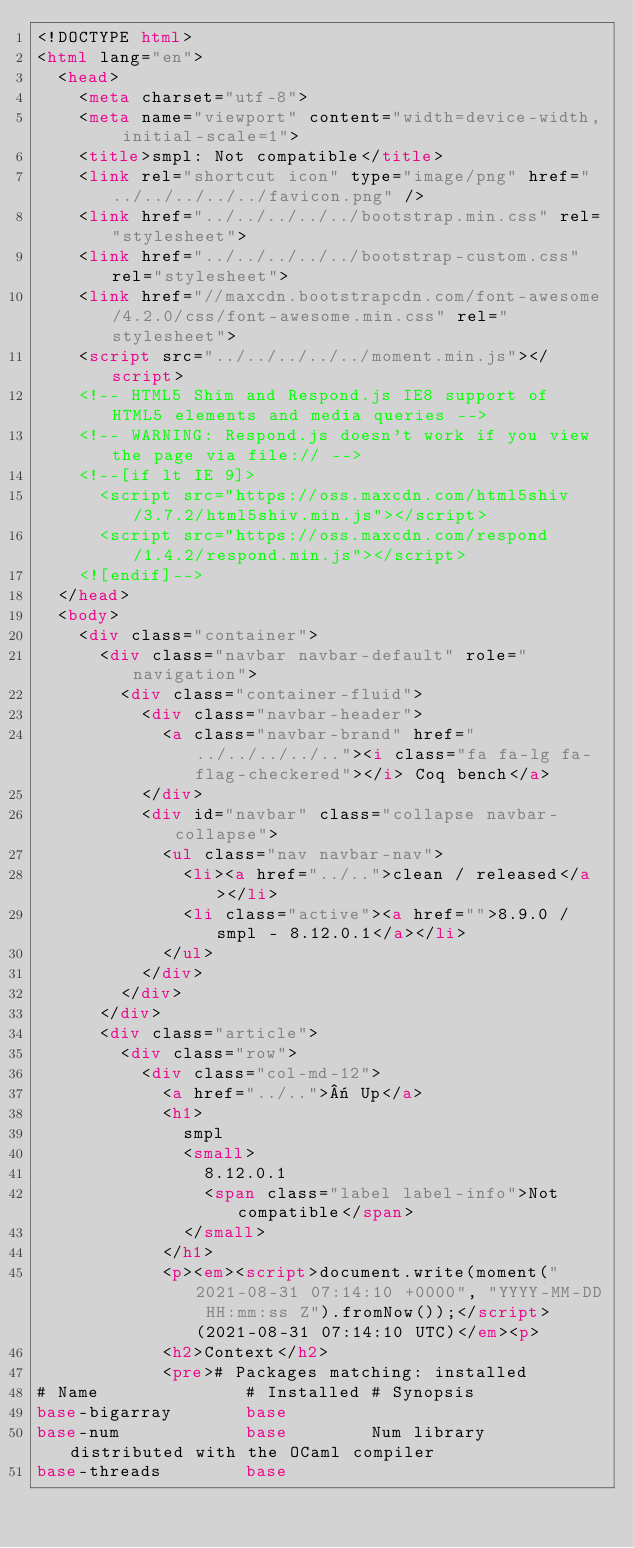<code> <loc_0><loc_0><loc_500><loc_500><_HTML_><!DOCTYPE html>
<html lang="en">
  <head>
    <meta charset="utf-8">
    <meta name="viewport" content="width=device-width, initial-scale=1">
    <title>smpl: Not compatible</title>
    <link rel="shortcut icon" type="image/png" href="../../../../../favicon.png" />
    <link href="../../../../../bootstrap.min.css" rel="stylesheet">
    <link href="../../../../../bootstrap-custom.css" rel="stylesheet">
    <link href="//maxcdn.bootstrapcdn.com/font-awesome/4.2.0/css/font-awesome.min.css" rel="stylesheet">
    <script src="../../../../../moment.min.js"></script>
    <!-- HTML5 Shim and Respond.js IE8 support of HTML5 elements and media queries -->
    <!-- WARNING: Respond.js doesn't work if you view the page via file:// -->
    <!--[if lt IE 9]>
      <script src="https://oss.maxcdn.com/html5shiv/3.7.2/html5shiv.min.js"></script>
      <script src="https://oss.maxcdn.com/respond/1.4.2/respond.min.js"></script>
    <![endif]-->
  </head>
  <body>
    <div class="container">
      <div class="navbar navbar-default" role="navigation">
        <div class="container-fluid">
          <div class="navbar-header">
            <a class="navbar-brand" href="../../../../.."><i class="fa fa-lg fa-flag-checkered"></i> Coq bench</a>
          </div>
          <div id="navbar" class="collapse navbar-collapse">
            <ul class="nav navbar-nav">
              <li><a href="../..">clean / released</a></li>
              <li class="active"><a href="">8.9.0 / smpl - 8.12.0.1</a></li>
            </ul>
          </div>
        </div>
      </div>
      <div class="article">
        <div class="row">
          <div class="col-md-12">
            <a href="../..">« Up</a>
            <h1>
              smpl
              <small>
                8.12.0.1
                <span class="label label-info">Not compatible</span>
              </small>
            </h1>
            <p><em><script>document.write(moment("2021-08-31 07:14:10 +0000", "YYYY-MM-DD HH:mm:ss Z").fromNow());</script> (2021-08-31 07:14:10 UTC)</em><p>
            <h2>Context</h2>
            <pre># Packages matching: installed
# Name              # Installed # Synopsis
base-bigarray       base
base-num            base        Num library distributed with the OCaml compiler
base-threads        base</code> 